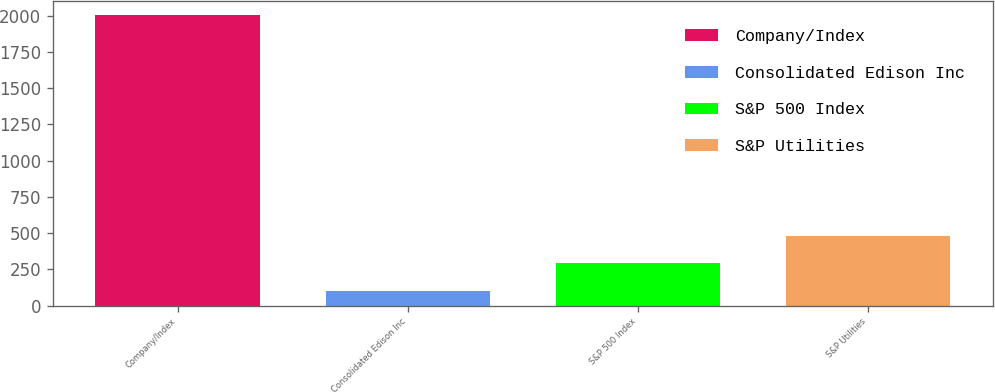Convert chart to OTSL. <chart><loc_0><loc_0><loc_500><loc_500><bar_chart><fcel>Company/Index<fcel>Consolidated Edison Inc<fcel>S&P 500 Index<fcel>S&P Utilities<nl><fcel>2005<fcel>100<fcel>290.5<fcel>481<nl></chart> 